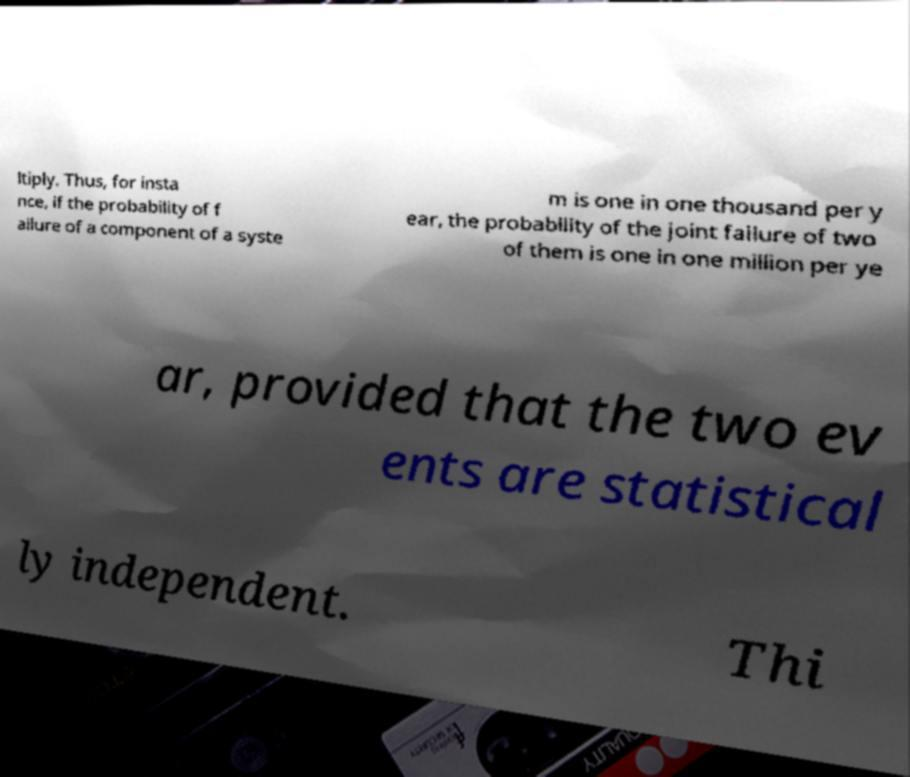Could you assist in decoding the text presented in this image and type it out clearly? ltiply. Thus, for insta nce, if the probability of f ailure of a component of a syste m is one in one thousand per y ear, the probability of the joint failure of two of them is one in one million per ye ar, provided that the two ev ents are statistical ly independent. Thi 